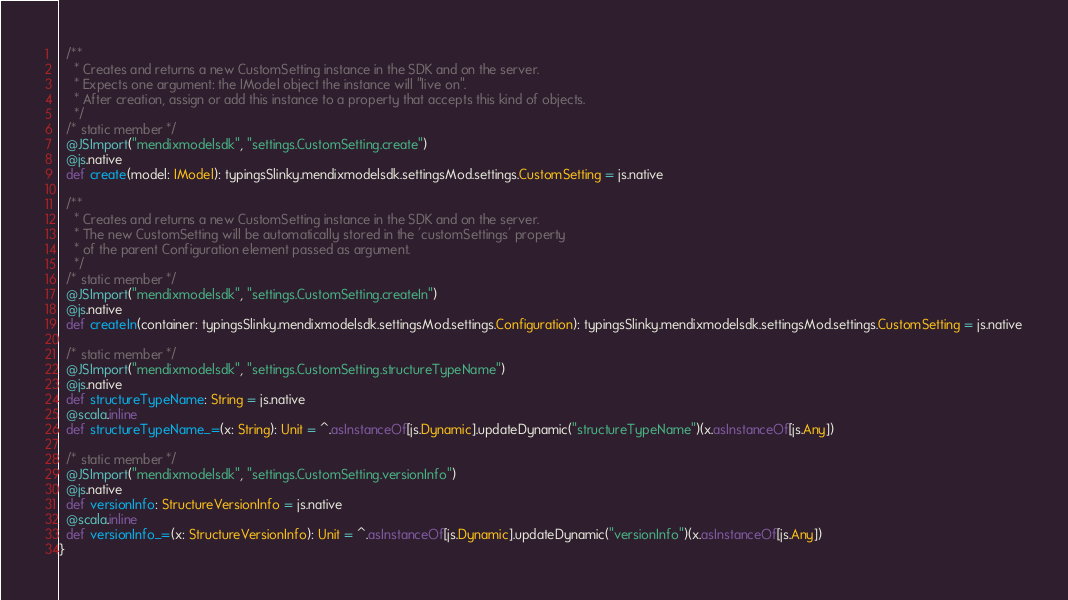<code> <loc_0><loc_0><loc_500><loc_500><_Scala_>  /**
    * Creates and returns a new CustomSetting instance in the SDK and on the server.
    * Expects one argument: the IModel object the instance will "live on".
    * After creation, assign or add this instance to a property that accepts this kind of objects.
    */
  /* static member */
  @JSImport("mendixmodelsdk", "settings.CustomSetting.create")
  @js.native
  def create(model: IModel): typingsSlinky.mendixmodelsdk.settingsMod.settings.CustomSetting = js.native
  
  /**
    * Creates and returns a new CustomSetting instance in the SDK and on the server.
    * The new CustomSetting will be automatically stored in the 'customSettings' property
    * of the parent Configuration element passed as argument.
    */
  /* static member */
  @JSImport("mendixmodelsdk", "settings.CustomSetting.createIn")
  @js.native
  def createIn(container: typingsSlinky.mendixmodelsdk.settingsMod.settings.Configuration): typingsSlinky.mendixmodelsdk.settingsMod.settings.CustomSetting = js.native
  
  /* static member */
  @JSImport("mendixmodelsdk", "settings.CustomSetting.structureTypeName")
  @js.native
  def structureTypeName: String = js.native
  @scala.inline
  def structureTypeName_=(x: String): Unit = ^.asInstanceOf[js.Dynamic].updateDynamic("structureTypeName")(x.asInstanceOf[js.Any])
  
  /* static member */
  @JSImport("mendixmodelsdk", "settings.CustomSetting.versionInfo")
  @js.native
  def versionInfo: StructureVersionInfo = js.native
  @scala.inline
  def versionInfo_=(x: StructureVersionInfo): Unit = ^.asInstanceOf[js.Dynamic].updateDynamic("versionInfo")(x.asInstanceOf[js.Any])
}
</code> 